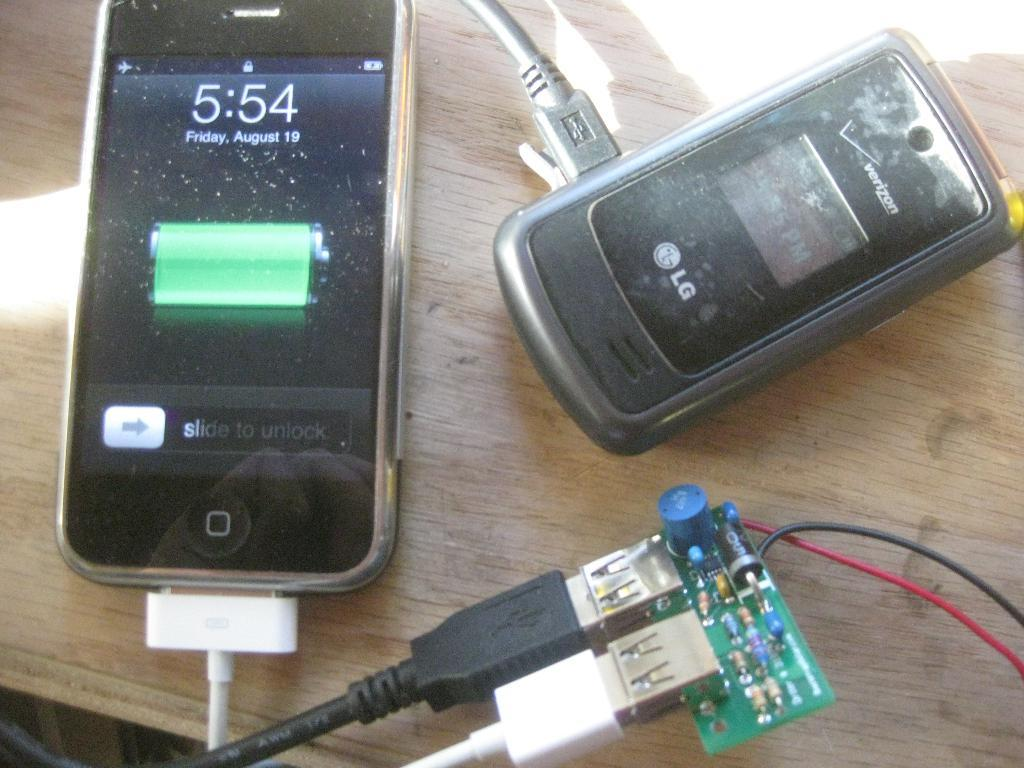<image>
Describe the image concisely. An LG flip phone and what looks like an iPod on a wooden table. 